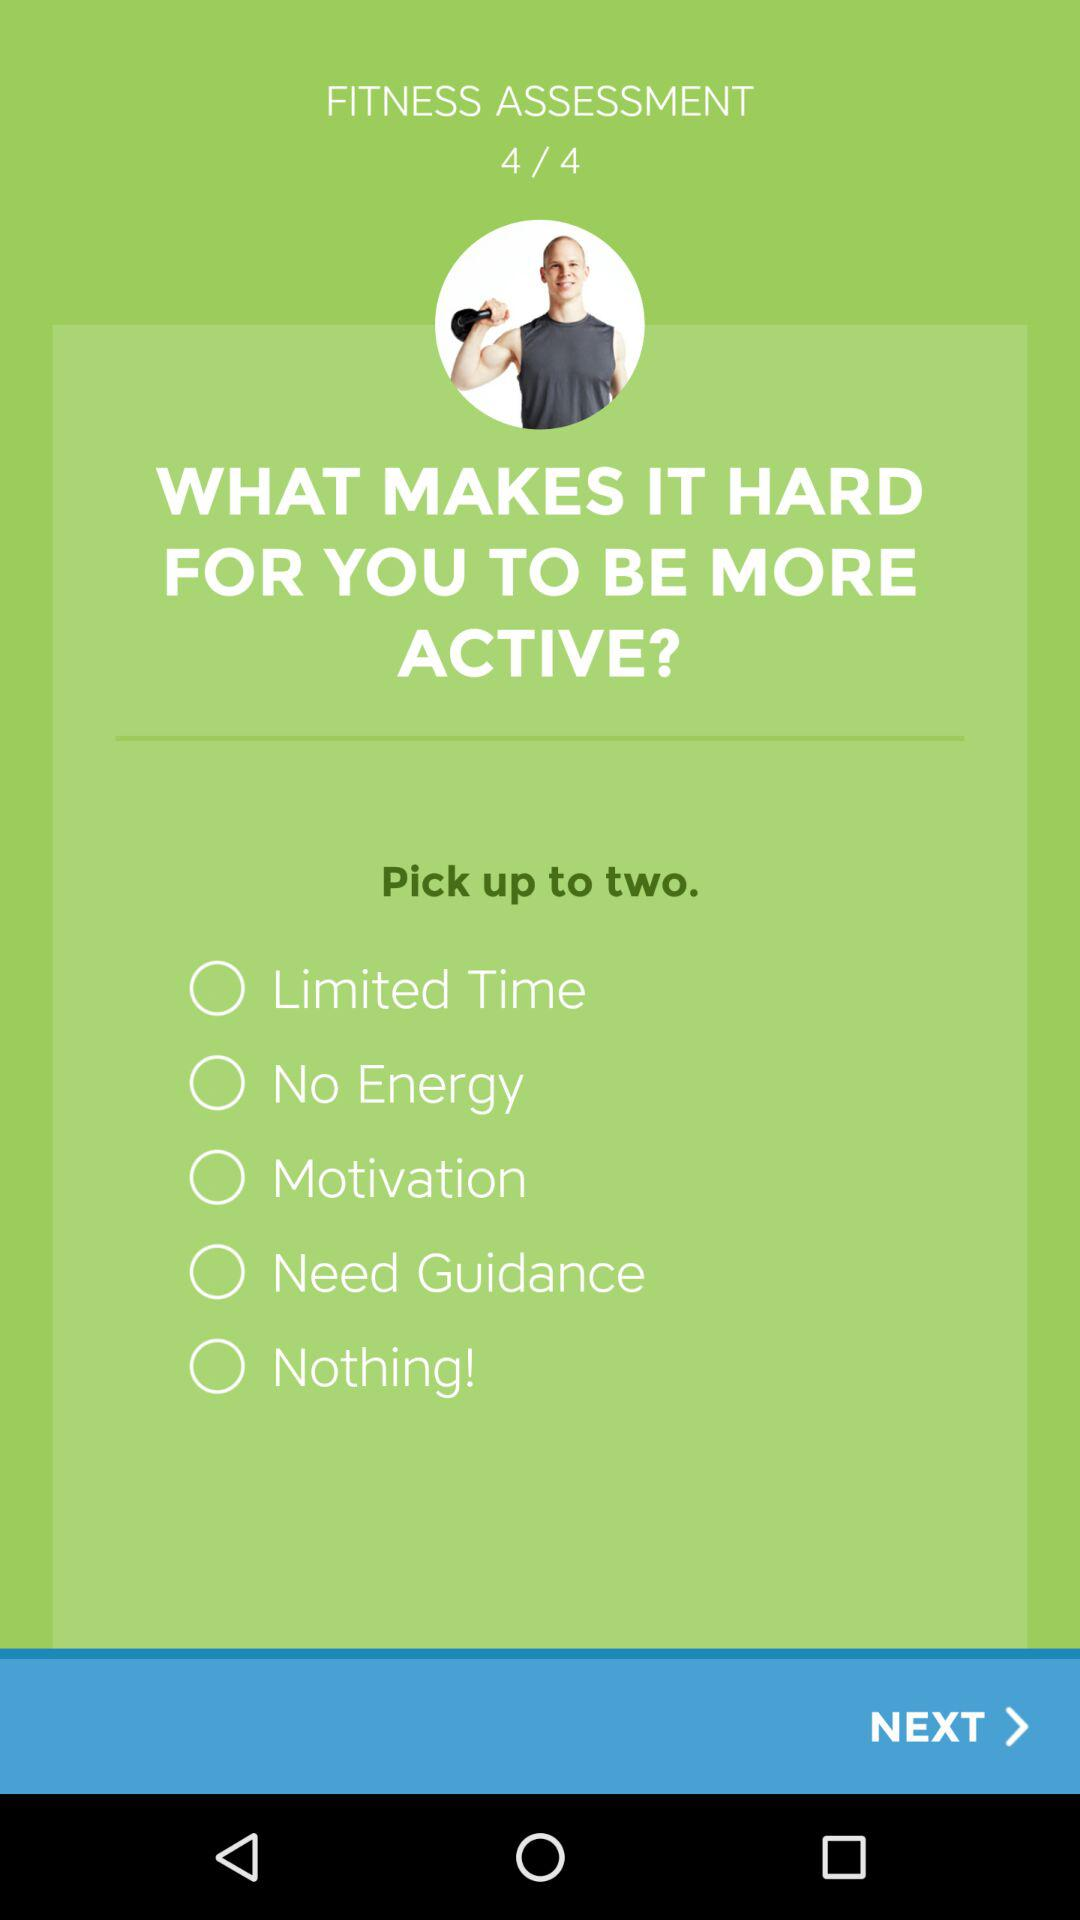At which fitness assessment am I? You are at fitness assessment 4. 